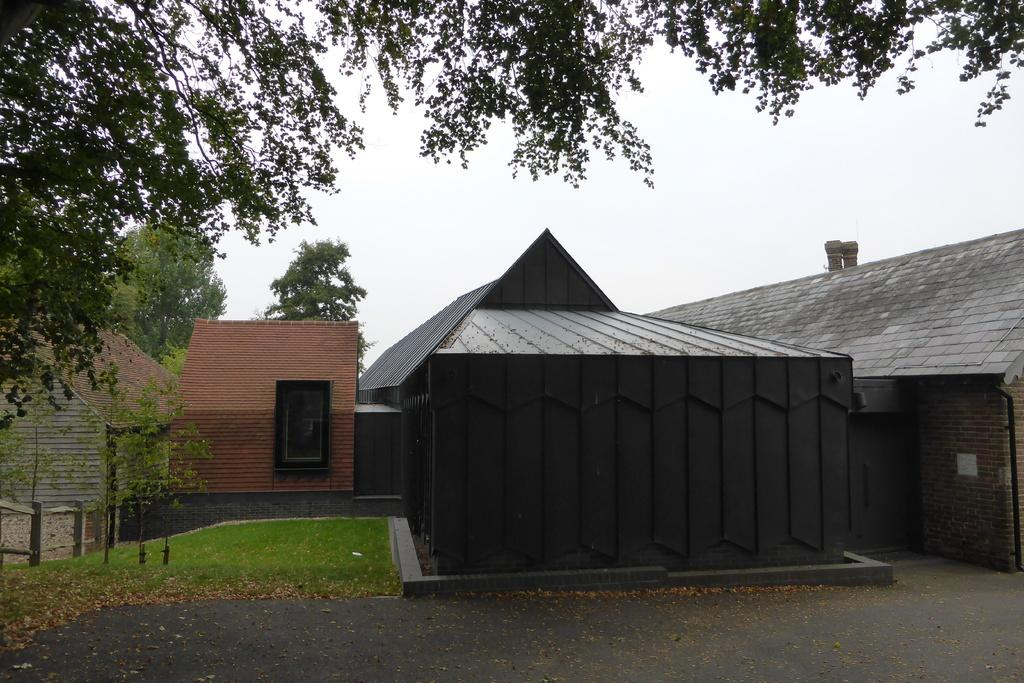What type of structures are visible in the image? There are houses in the image. What type of terrain is at the bottom side of the image? There is grassland at the bottom side of the image. What type of vegetation can be seen in the background of the image? There are trees in the background of the image. Are there any trees visible at the top side of the image? Yes, there are trees at the top side of the image. Can you see any waves crashing on the edge of the image? There are no waves or edges visible in the image; it features houses, grassland, and trees. 